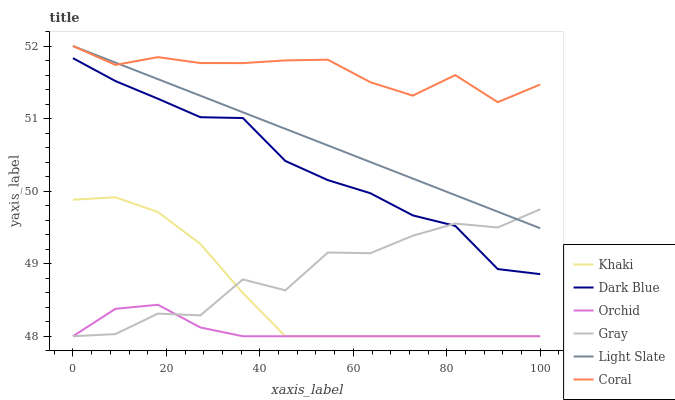Does Orchid have the minimum area under the curve?
Answer yes or no. Yes. Does Coral have the maximum area under the curve?
Answer yes or no. Yes. Does Khaki have the minimum area under the curve?
Answer yes or no. No. Does Khaki have the maximum area under the curve?
Answer yes or no. No. Is Light Slate the smoothest?
Answer yes or no. Yes. Is Gray the roughest?
Answer yes or no. Yes. Is Khaki the smoothest?
Answer yes or no. No. Is Khaki the roughest?
Answer yes or no. No. Does Gray have the lowest value?
Answer yes or no. Yes. Does Light Slate have the lowest value?
Answer yes or no. No. Does Coral have the highest value?
Answer yes or no. Yes. Does Khaki have the highest value?
Answer yes or no. No. Is Orchid less than Dark Blue?
Answer yes or no. Yes. Is Coral greater than Khaki?
Answer yes or no. Yes. Does Gray intersect Light Slate?
Answer yes or no. Yes. Is Gray less than Light Slate?
Answer yes or no. No. Is Gray greater than Light Slate?
Answer yes or no. No. Does Orchid intersect Dark Blue?
Answer yes or no. No. 